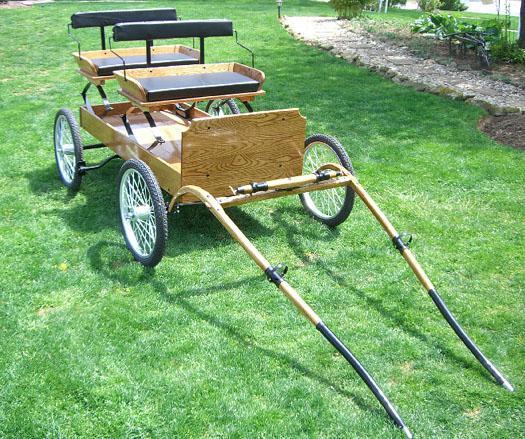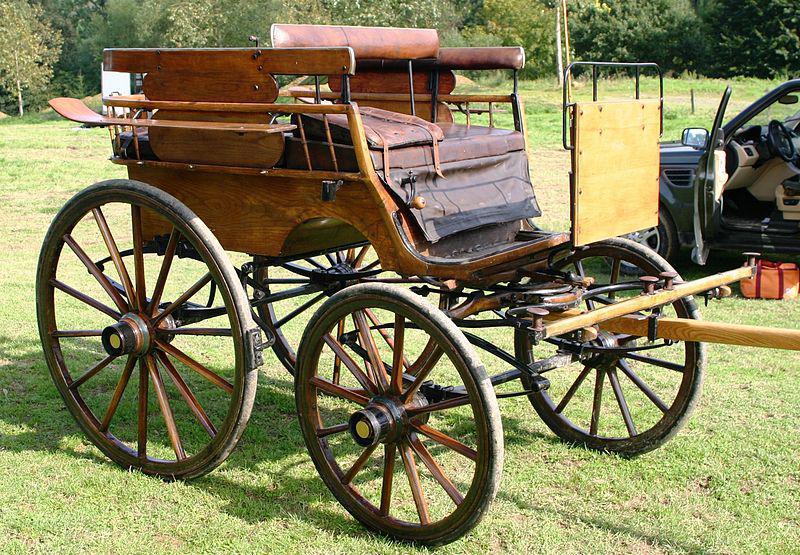The first image is the image on the left, the second image is the image on the right. Analyze the images presented: Is the assertion "The wheels in one of the images have metal spokes." valid? Answer yes or no. Yes. 